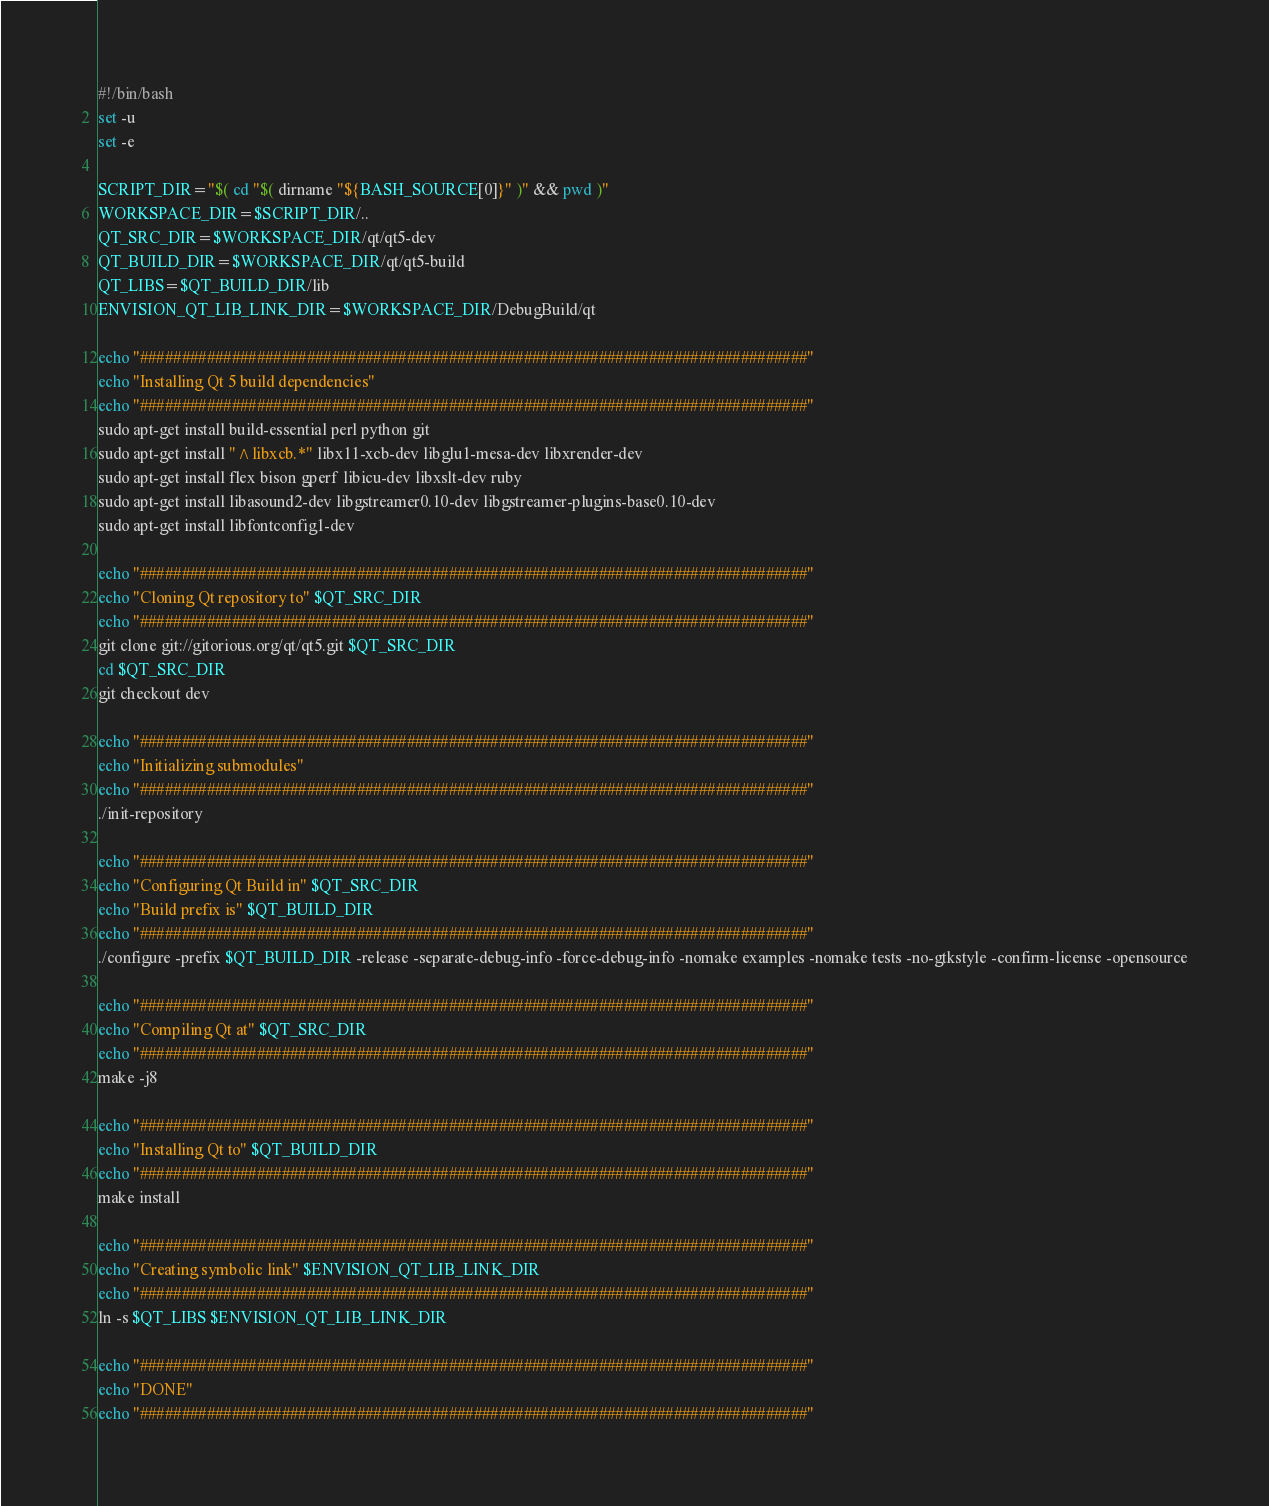Convert code to text. <code><loc_0><loc_0><loc_500><loc_500><_Bash_>#!/bin/bash
set -u
set -e

SCRIPT_DIR="$( cd "$( dirname "${BASH_SOURCE[0]}" )" && pwd )"
WORKSPACE_DIR=$SCRIPT_DIR/..
QT_SRC_DIR=$WORKSPACE_DIR/qt/qt5-dev
QT_BUILD_DIR=$WORKSPACE_DIR/qt/qt5-build
QT_LIBS=$QT_BUILD_DIR/lib
ENVISION_QT_LIB_LINK_DIR=$WORKSPACE_DIR/DebugBuild/qt

echo "################################################################################"
echo "Installing Qt 5 build dependencies"
echo "################################################################################"
sudo apt-get install build-essential perl python git
sudo apt-get install "^libxcb.*" libx11-xcb-dev libglu1-mesa-dev libxrender-dev
sudo apt-get install flex bison gperf libicu-dev libxslt-dev ruby
sudo apt-get install libasound2-dev libgstreamer0.10-dev libgstreamer-plugins-base0.10-dev
sudo apt-get install libfontconfig1-dev

echo "################################################################################"
echo "Cloning Qt repository to" $QT_SRC_DIR
echo "################################################################################"
git clone git://gitorious.org/qt/qt5.git $QT_SRC_DIR
cd $QT_SRC_DIR
git checkout dev

echo "################################################################################"
echo "Initializing submodules"
echo "################################################################################"
./init-repository

echo "################################################################################"
echo "Configuring Qt Build in" $QT_SRC_DIR
echo "Build prefix is" $QT_BUILD_DIR
echo "################################################################################"
./configure -prefix $QT_BUILD_DIR -release -separate-debug-info -force-debug-info -nomake examples -nomake tests -no-gtkstyle -confirm-license -opensource

echo "################################################################################"
echo "Compiling Qt at" $QT_SRC_DIR
echo "################################################################################"
make -j8

echo "################################################################################"
echo "Installing Qt to" $QT_BUILD_DIR
echo "################################################################################"
make install

echo "################################################################################"
echo "Creating symbolic link" $ENVISION_QT_LIB_LINK_DIR
echo "################################################################################"
ln -s $QT_LIBS $ENVISION_QT_LIB_LINK_DIR

echo "################################################################################"
echo "DONE"
echo "################################################################################"</code> 